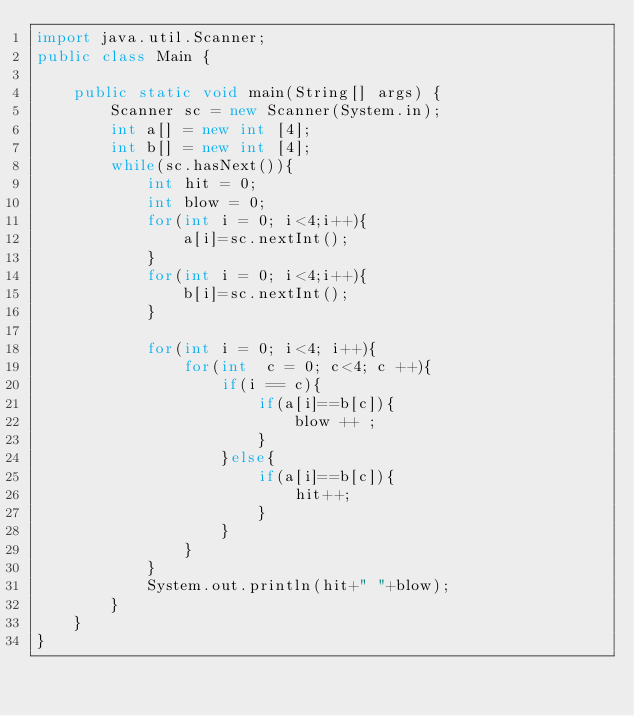<code> <loc_0><loc_0><loc_500><loc_500><_Java_>import java.util.Scanner;
public class Main {

	public static void main(String[] args) {
		Scanner sc = new Scanner(System.in);
		int a[] = new int [4];
		int b[] = new int [4];		
		while(sc.hasNext()){
			int hit = 0;
			int blow = 0;
			for(int i = 0; i<4;i++){
				a[i]=sc.nextInt();
			}
			for(int i = 0; i<4;i++){
				b[i]=sc.nextInt();
			}
			
			for(int i = 0; i<4; i++){
				for(int  c = 0; c<4; c ++){
					if(i == c){
						if(a[i]==b[c]){
							blow ++ ;
						}
					}else{
						if(a[i]==b[c]){
							hit++;
						}
					}
				}
			}
			System.out.println(hit+" "+blow);
		}
	}
}</code> 